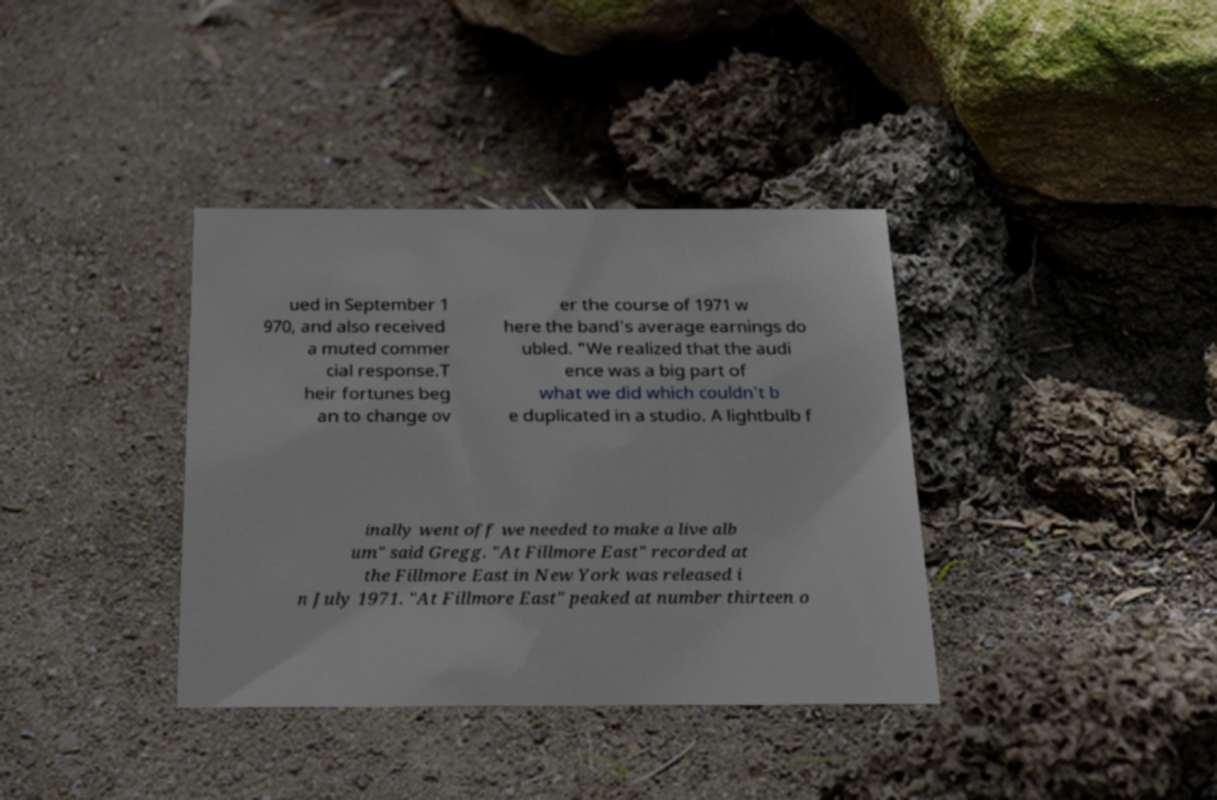Please identify and transcribe the text found in this image. ued in September 1 970, and also received a muted commer cial response.T heir fortunes beg an to change ov er the course of 1971 w here the band's average earnings do ubled. "We realized that the audi ence was a big part of what we did which couldn't b e duplicated in a studio. A lightbulb f inally went off we needed to make a live alb um" said Gregg. "At Fillmore East" recorded at the Fillmore East in New York was released i n July 1971. "At Fillmore East" peaked at number thirteen o 